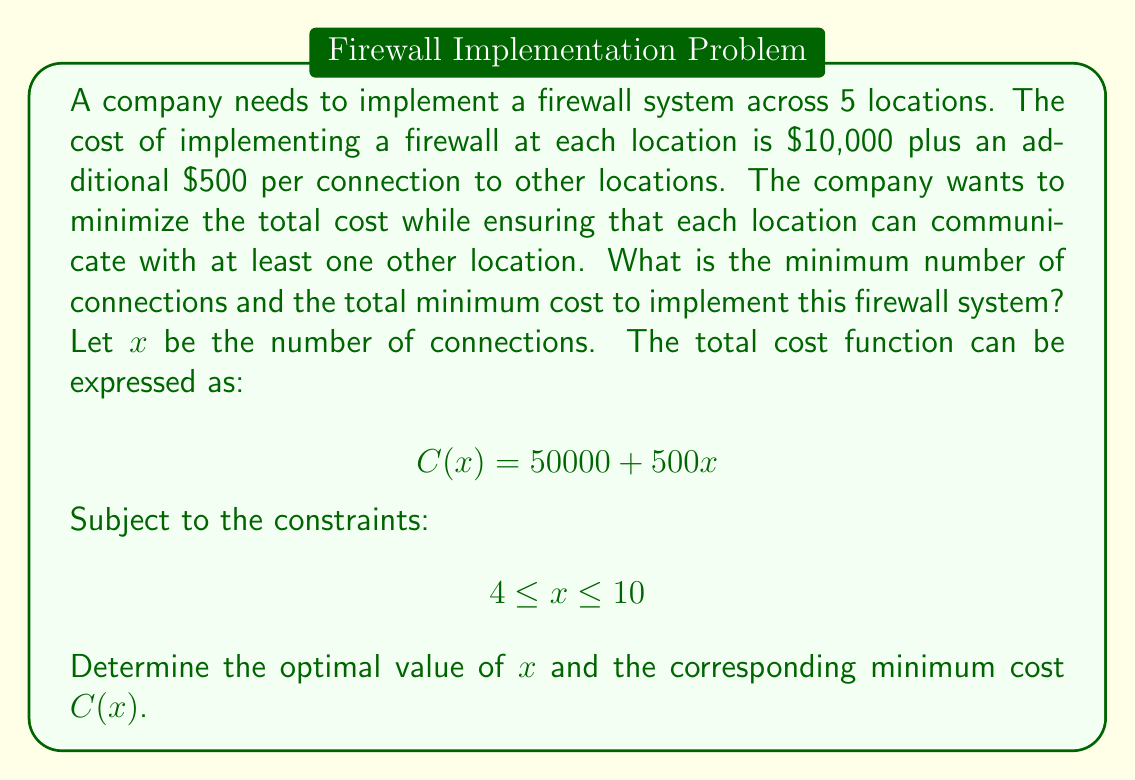Provide a solution to this math problem. To solve this optimization problem, we need to consider the constraints and the nature of the cost function:

1. The cost function $C(x) = 50000 + 500x$ is linear, increasing with the number of connections.

2. The lower bound of 4 connections ensures that each of the 5 locations can communicate with at least one other location (minimum spanning tree configuration).

3. The upper bound of 10 connections represents the maximum possible connections in a network of 5 locations (complete graph configuration).

Given that the cost function is linear and increasing, the minimum cost will occur at the lower bound of the constraint, which is 4 connections.

To calculate the minimum cost:

$$C(4) = 50000 + 500(4)$$
$$C(4) = 50000 + 2000$$
$$C(4) = 52000$$

Therefore, the minimum number of connections is 4, and the total minimum cost is $52,000.

This solution represents a minimal spanning tree configuration for the network, where each location is connected to at least one other location with the minimum number of total connections.
Answer: The minimum number of connections: 4
The total minimum cost: $52,000 